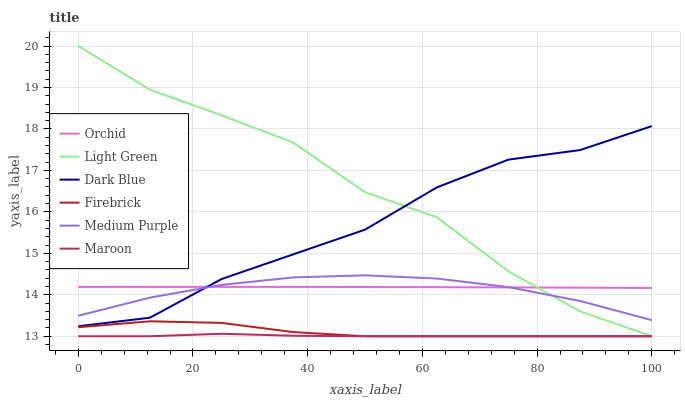Does Maroon have the minimum area under the curve?
Answer yes or no. Yes. Does Medium Purple have the minimum area under the curve?
Answer yes or no. No. Does Medium Purple have the maximum area under the curve?
Answer yes or no. No. Is Orchid the smoothest?
Answer yes or no. Yes. Is Light Green the roughest?
Answer yes or no. Yes. Is Maroon the smoothest?
Answer yes or no. No. Is Maroon the roughest?
Answer yes or no. No. Does Medium Purple have the lowest value?
Answer yes or no. No. Does Medium Purple have the highest value?
Answer yes or no. No. Is Firebrick less than Medium Purple?
Answer yes or no. Yes. Is Medium Purple greater than Maroon?
Answer yes or no. Yes. Does Firebrick intersect Medium Purple?
Answer yes or no. No. 